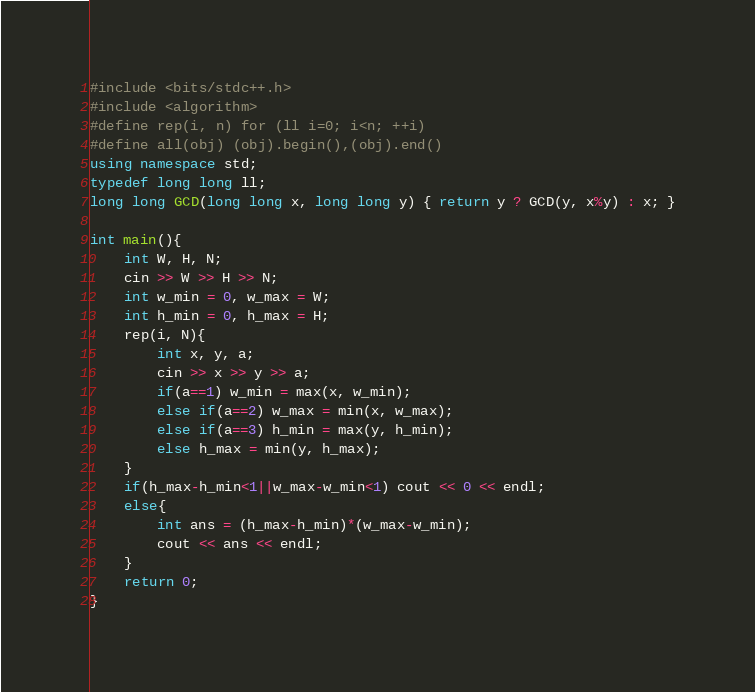Convert code to text. <code><loc_0><loc_0><loc_500><loc_500><_C++_>#include <bits/stdc++.h>
#include <algorithm>
#define rep(i, n) for (ll i=0; i<n; ++i)
#define all(obj) (obj).begin(),(obj).end()
using namespace std;
typedef long long ll;
long long GCD(long long x, long long y) { return y ? GCD(y, x%y) : x; }

int main(){
    int W, H, N;
    cin >> W >> H >> N;
    int w_min = 0, w_max = W;
    int h_min = 0, h_max = H;
    rep(i, N){
        int x, y, a;
        cin >> x >> y >> a;
        if(a==1) w_min = max(x, w_min);
        else if(a==2) w_max = min(x, w_max);
        else if(a==3) h_min = max(y, h_min);
        else h_max = min(y, h_max);
    }
    if(h_max-h_min<1||w_max-w_min<1) cout << 0 << endl;
    else{
        int ans = (h_max-h_min)*(w_max-w_min);
        cout << ans << endl;
    }
    return 0;
}
</code> 